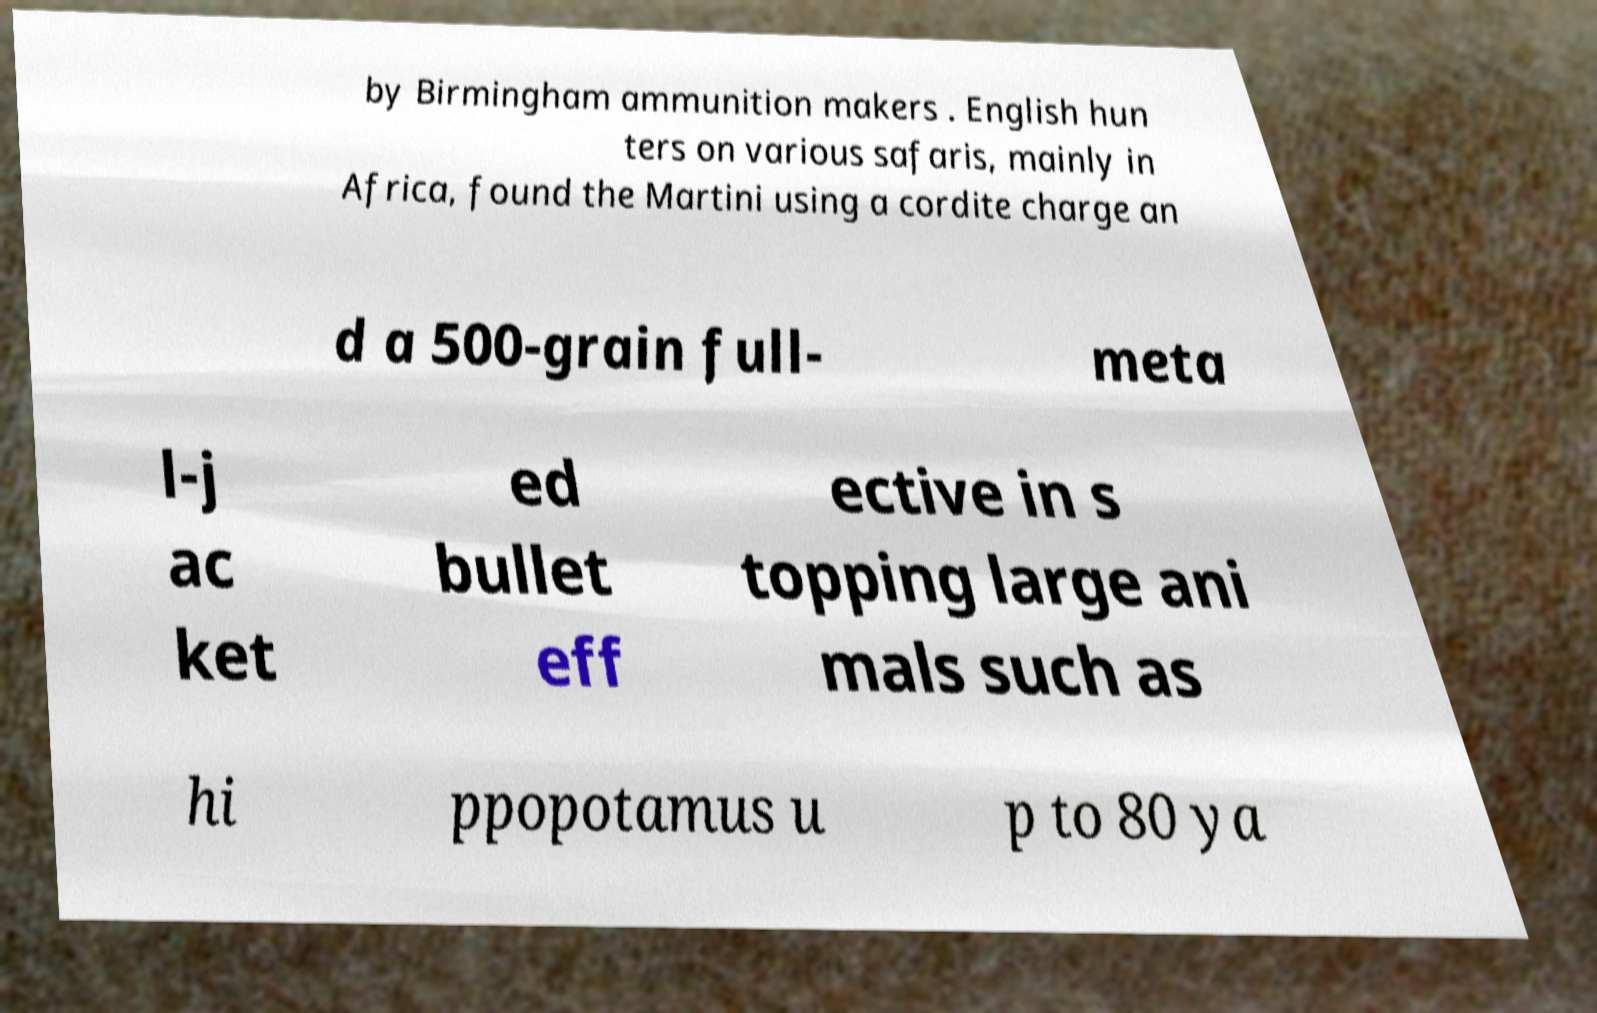Can you read and provide the text displayed in the image?This photo seems to have some interesting text. Can you extract and type it out for me? by Birmingham ammunition makers . English hun ters on various safaris, mainly in Africa, found the Martini using a cordite charge an d a 500-grain full- meta l-j ac ket ed bullet eff ective in s topping large ani mals such as hi ppopotamus u p to 80 ya 